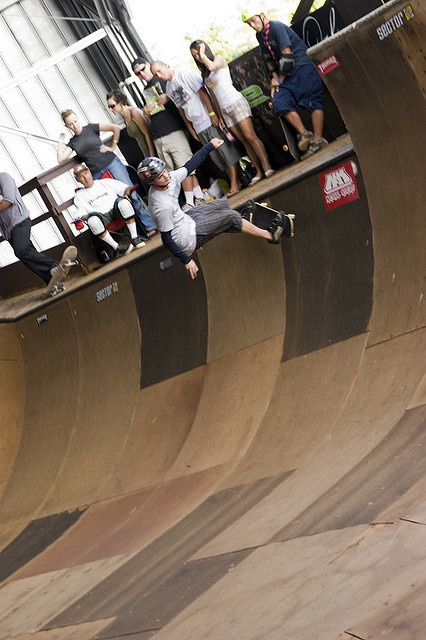Describe the objects in this image and their specific colors. I can see people in lightgray, black, gray, and darkgray tones, people in lightgray, black, navy, gray, and ivory tones, people in lightgray, white, black, gray, and darkgray tones, people in lightgray, black, gray, and darkgray tones, and people in lightgray, black, darkgray, and gray tones in this image. 